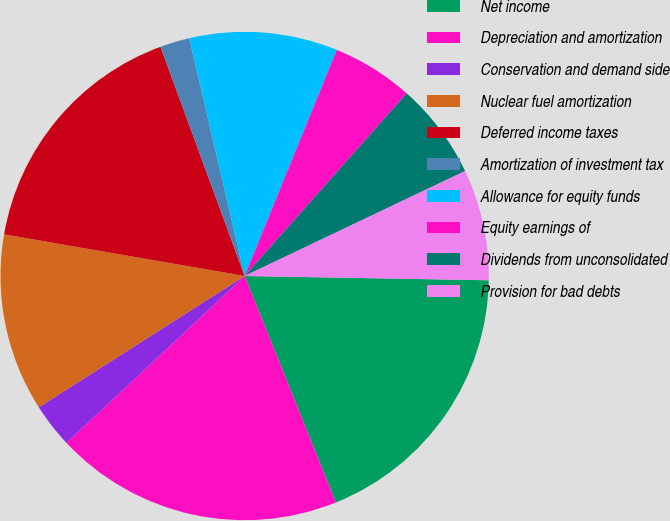<chart> <loc_0><loc_0><loc_500><loc_500><pie_chart><fcel>Net income<fcel>Depreciation and amortization<fcel>Conservation and demand side<fcel>Nuclear fuel amortization<fcel>Deferred income taxes<fcel>Amortization of investment tax<fcel>Allowance for equity funds<fcel>Equity earnings of<fcel>Dividends from unconsolidated<fcel>Provision for bad debts<nl><fcel>18.62%<fcel>19.11%<fcel>2.94%<fcel>11.76%<fcel>16.66%<fcel>1.96%<fcel>9.8%<fcel>5.39%<fcel>6.37%<fcel>7.35%<nl></chart> 